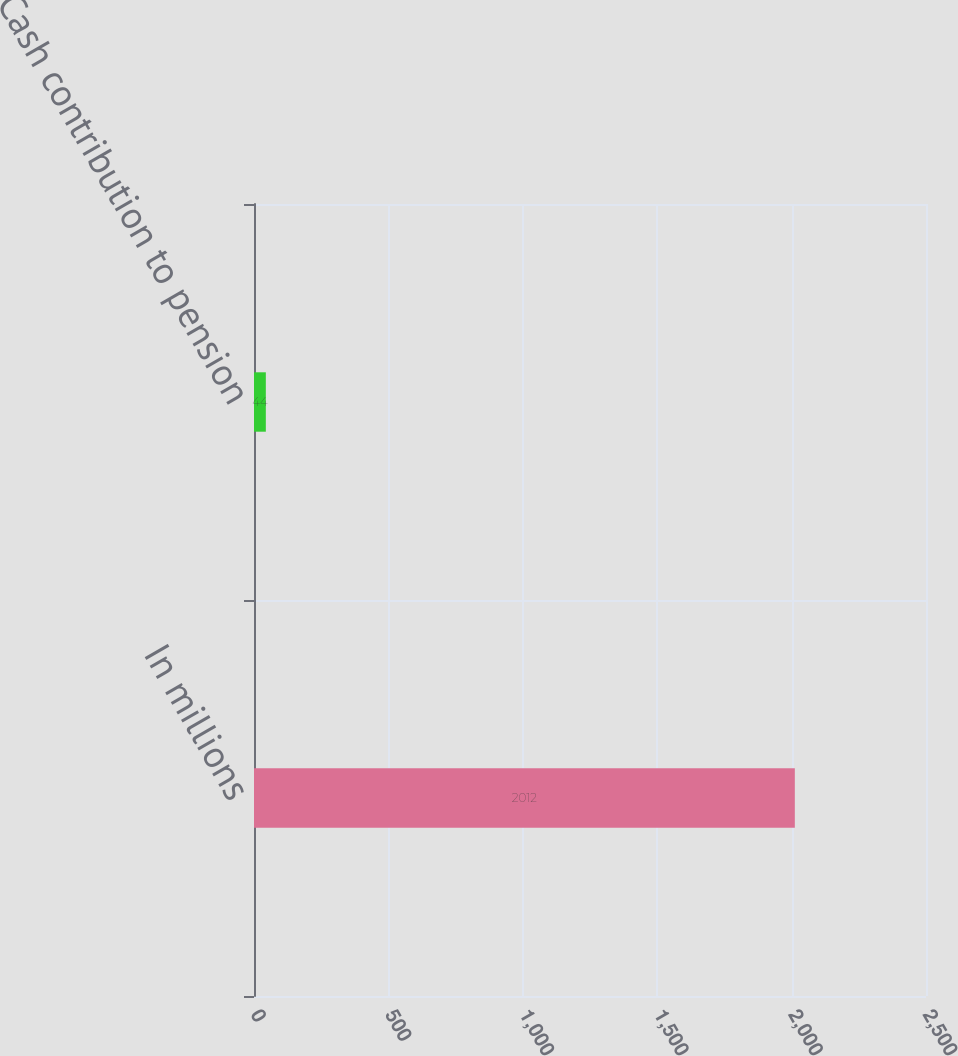<chart> <loc_0><loc_0><loc_500><loc_500><bar_chart><fcel>In millions<fcel>Cash contribution to pension<nl><fcel>2012<fcel>44<nl></chart> 